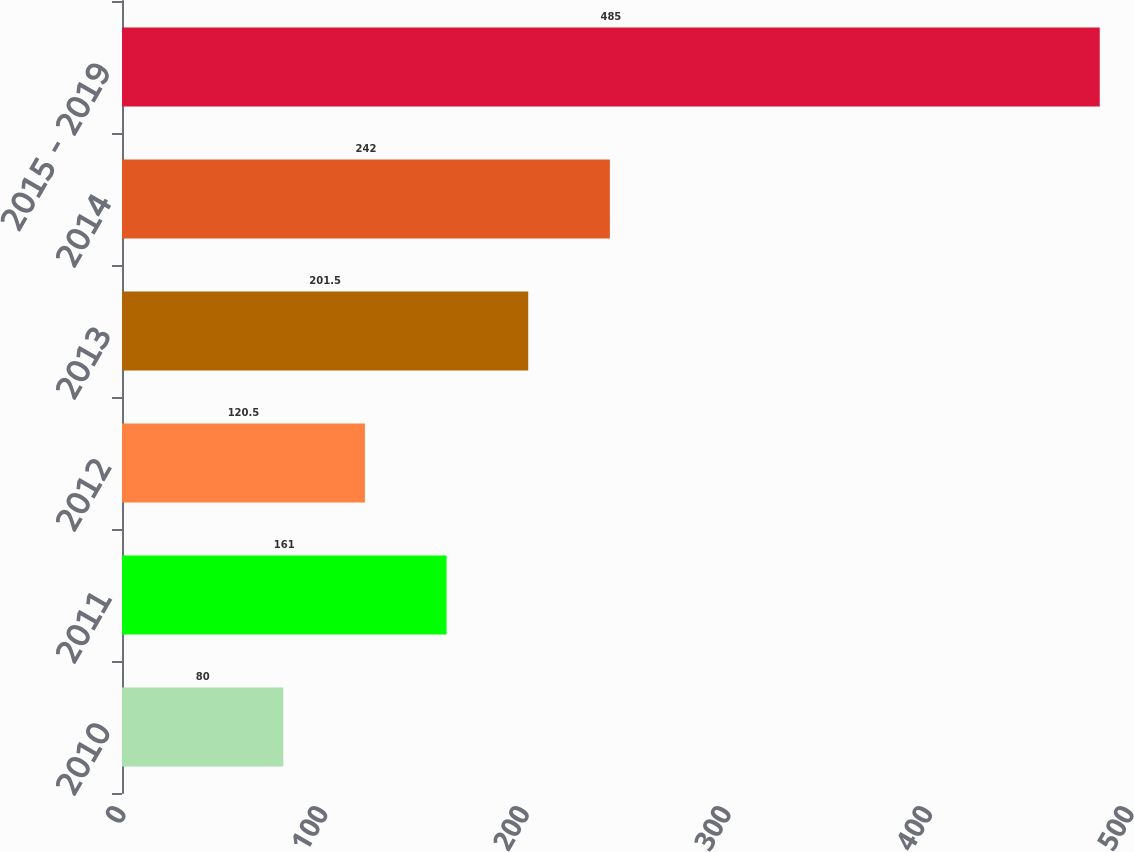Convert chart. <chart><loc_0><loc_0><loc_500><loc_500><bar_chart><fcel>2010<fcel>2011<fcel>2012<fcel>2013<fcel>2014<fcel>2015 - 2019<nl><fcel>80<fcel>161<fcel>120.5<fcel>201.5<fcel>242<fcel>485<nl></chart> 